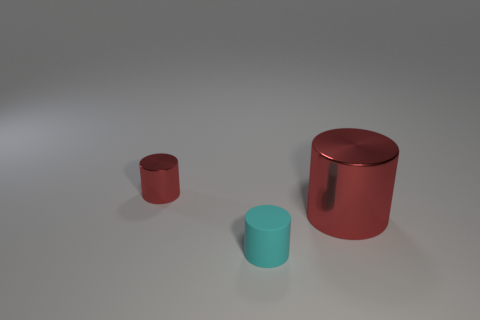Is the color of the large cylinder the same as the tiny matte object?
Keep it short and to the point. No. There is a rubber cylinder that is to the right of the tiny thing that is on the left side of the small rubber cylinder; what size is it?
Your response must be concise. Small. What number of tiny cylinders are the same color as the large metallic cylinder?
Keep it short and to the point. 1. What is the shape of the thing behind the red metallic cylinder that is on the right side of the tiny red metallic object?
Make the answer very short. Cylinder. How many large red things have the same material as the cyan cylinder?
Offer a terse response. 0. There is a small cylinder in front of the big object; what material is it?
Offer a terse response. Rubber. What is the shape of the tiny thing that is to the left of the cyan rubber thing on the left side of the metal cylinder that is to the right of the tiny cyan rubber thing?
Your answer should be compact. Cylinder. There is a small metal cylinder that is left of the large red shiny object; does it have the same color as the cylinder right of the matte thing?
Provide a succinct answer. Yes. Is the number of metal cylinders to the left of the tiny red shiny thing less than the number of things left of the cyan object?
Keep it short and to the point. Yes. Is there any other thing that is the same shape as the small red shiny object?
Provide a short and direct response. Yes. 